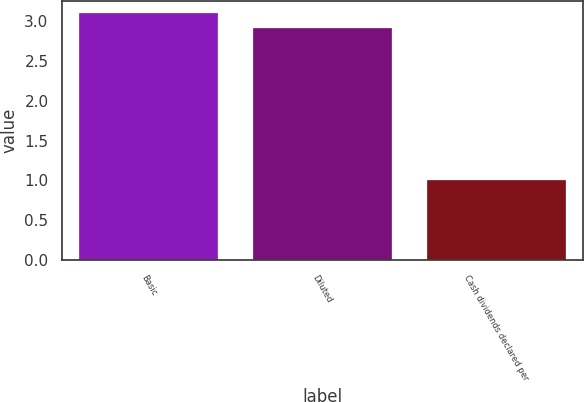Convert chart to OTSL. <chart><loc_0><loc_0><loc_500><loc_500><bar_chart><fcel>Basic<fcel>Diluted<fcel>Cash dividends declared per<nl><fcel>3.1<fcel>2.91<fcel>1.01<nl></chart> 